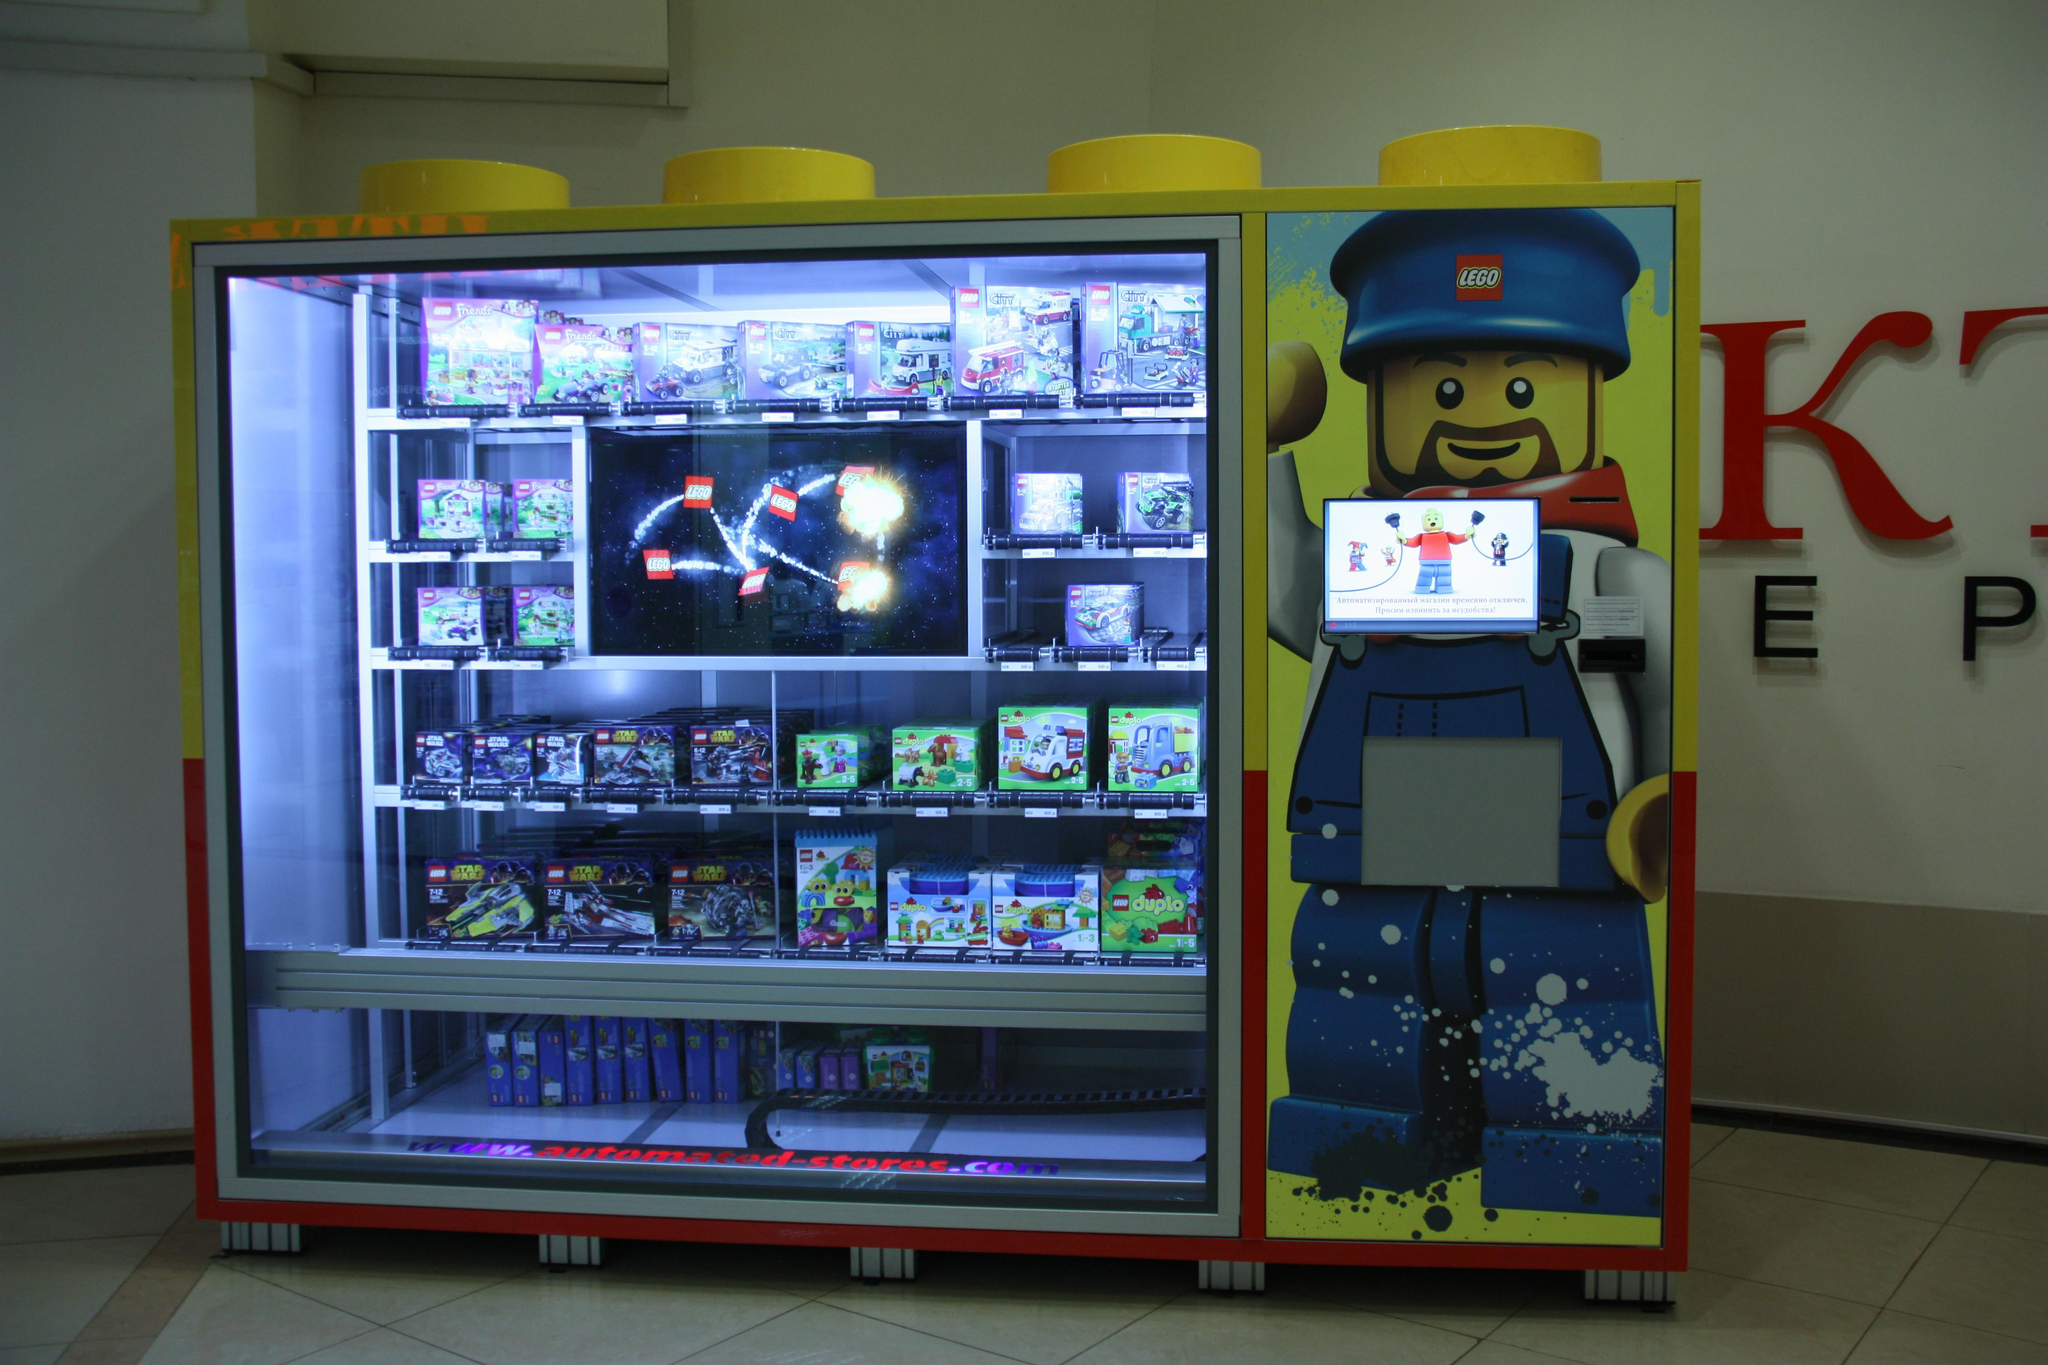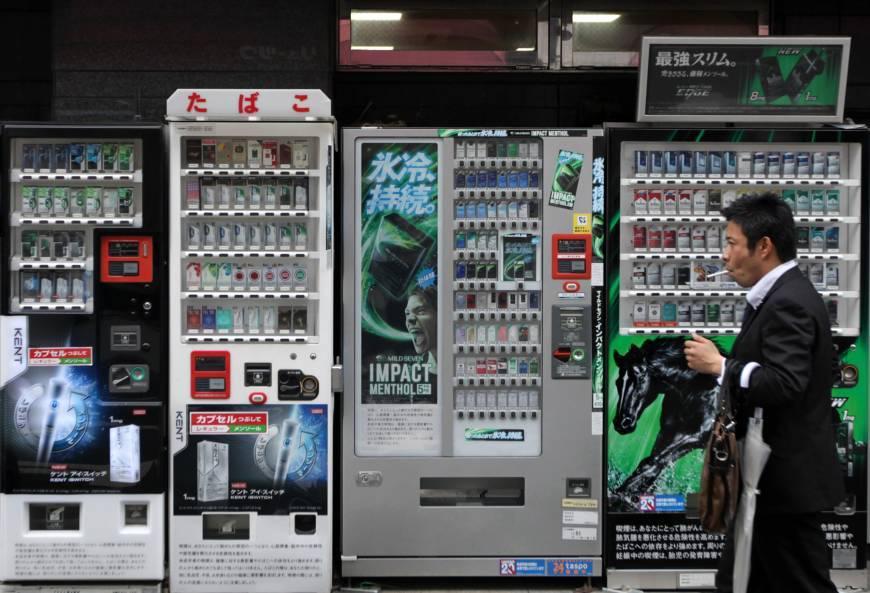The first image is the image on the left, the second image is the image on the right. For the images displayed, is the sentence "One of the image contains one or more vending machines that are facing to the left." factually correct? Answer yes or no. No. The first image is the image on the left, the second image is the image on the right. Analyze the images presented: Is the assertion "At least one image shows three or more vending machines." valid? Answer yes or no. Yes. 